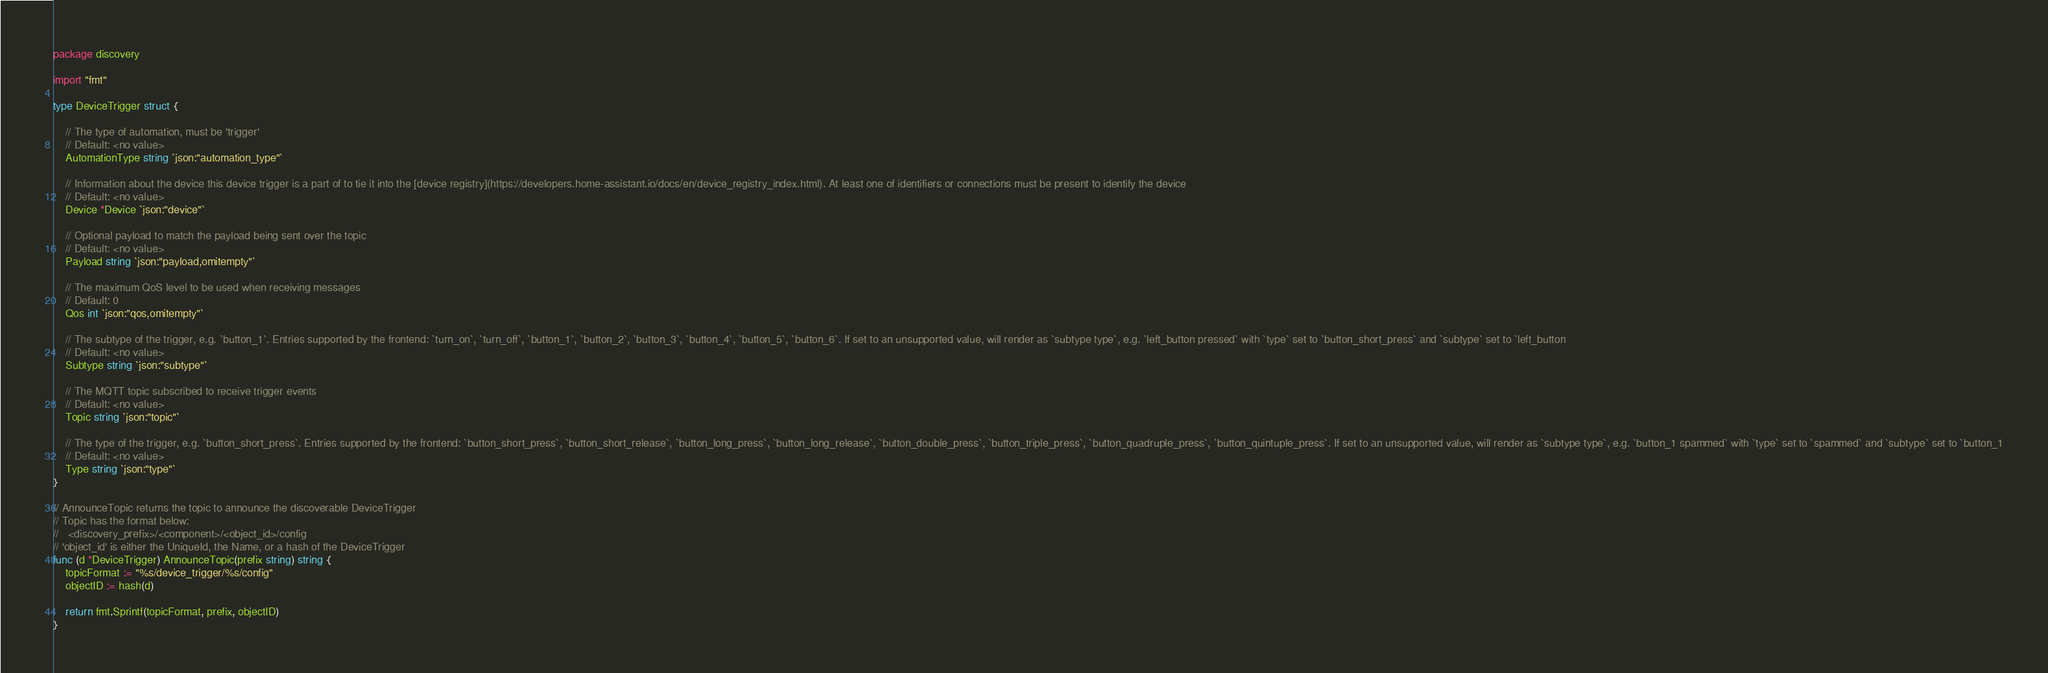<code> <loc_0><loc_0><loc_500><loc_500><_Go_>package discovery

import "fmt"

type DeviceTrigger struct {

	// The type of automation, must be 'trigger'
	// Default: <no value>
	AutomationType string `json:"automation_type"`

	// Information about the device this device trigger is a part of to tie it into the [device registry](https://developers.home-assistant.io/docs/en/device_registry_index.html). At least one of identifiers or connections must be present to identify the device
	// Default: <no value>
	Device *Device `json:"device"`

	// Optional payload to match the payload being sent over the topic
	// Default: <no value>
	Payload string `json:"payload,omitempty"`

	// The maximum QoS level to be used when receiving messages
	// Default: 0
	Qos int `json:"qos,omitempty"`

	// The subtype of the trigger, e.g. `button_1`. Entries supported by the frontend: `turn_on`, `turn_off`, `button_1`, `button_2`, `button_3`, `button_4`, `button_5`, `button_6`. If set to an unsupported value, will render as `subtype type`, e.g. `left_button pressed` with `type` set to `button_short_press` and `subtype` set to `left_button
	// Default: <no value>
	Subtype string `json:"subtype"`

	// The MQTT topic subscribed to receive trigger events
	// Default: <no value>
	Topic string `json:"topic"`

	// The type of the trigger, e.g. `button_short_press`. Entries supported by the frontend: `button_short_press`, `button_short_release`, `button_long_press`, `button_long_release`, `button_double_press`, `button_triple_press`, `button_quadruple_press`, `button_quintuple_press`. If set to an unsupported value, will render as `subtype type`, e.g. `button_1 spammed` with `type` set to `spammed` and `subtype` set to `button_1
	// Default: <no value>
	Type string `json:"type"`
}

// AnnounceTopic returns the topic to announce the discoverable DeviceTrigger
// Topic has the format below:
//   <discovery_prefix>/<component>/<object_id>/config
// 'object_id' is either the UniqueId, the Name, or a hash of the DeviceTrigger
func (d *DeviceTrigger) AnnounceTopic(prefix string) string {
	topicFormat := "%s/device_trigger/%s/config"
	objectID := hash(d)

	return fmt.Sprintf(topicFormat, prefix, objectID)
}
</code> 